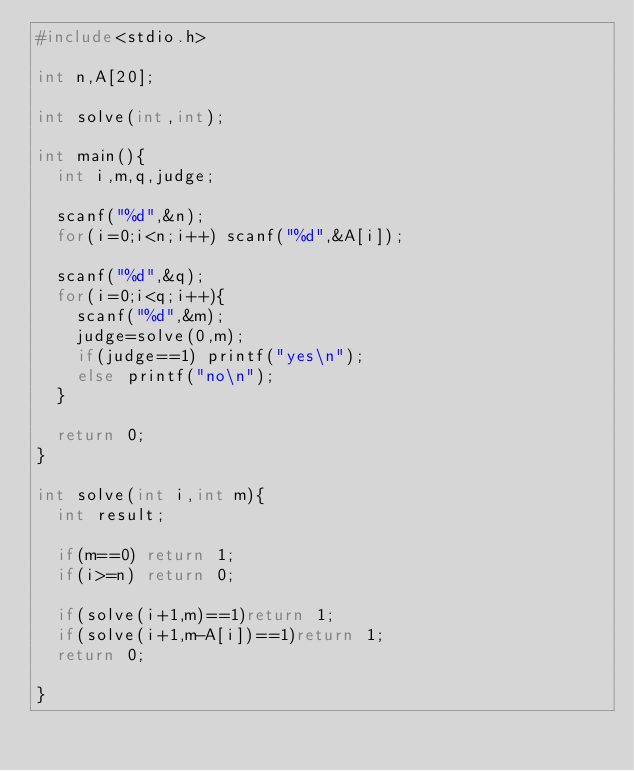Convert code to text. <code><loc_0><loc_0><loc_500><loc_500><_C_>#include<stdio.h>

int n,A[20];

int solve(int,int);

int main(){
  int i,m,q,judge;

  scanf("%d",&n);
  for(i=0;i<n;i++) scanf("%d",&A[i]);

  scanf("%d",&q);
  for(i=0;i<q;i++){
    scanf("%d",&m);
    judge=solve(0,m);
    if(judge==1) printf("yes\n");
    else printf("no\n");
  }
  
  return 0;
}

int solve(int i,int m){
  int result;
  
  if(m==0) return 1;
  if(i>=n) return 0;
  
  if(solve(i+1,m)==1)return 1;
  if(solve(i+1,m-A[i])==1)return 1;
  return 0;

}

</code> 